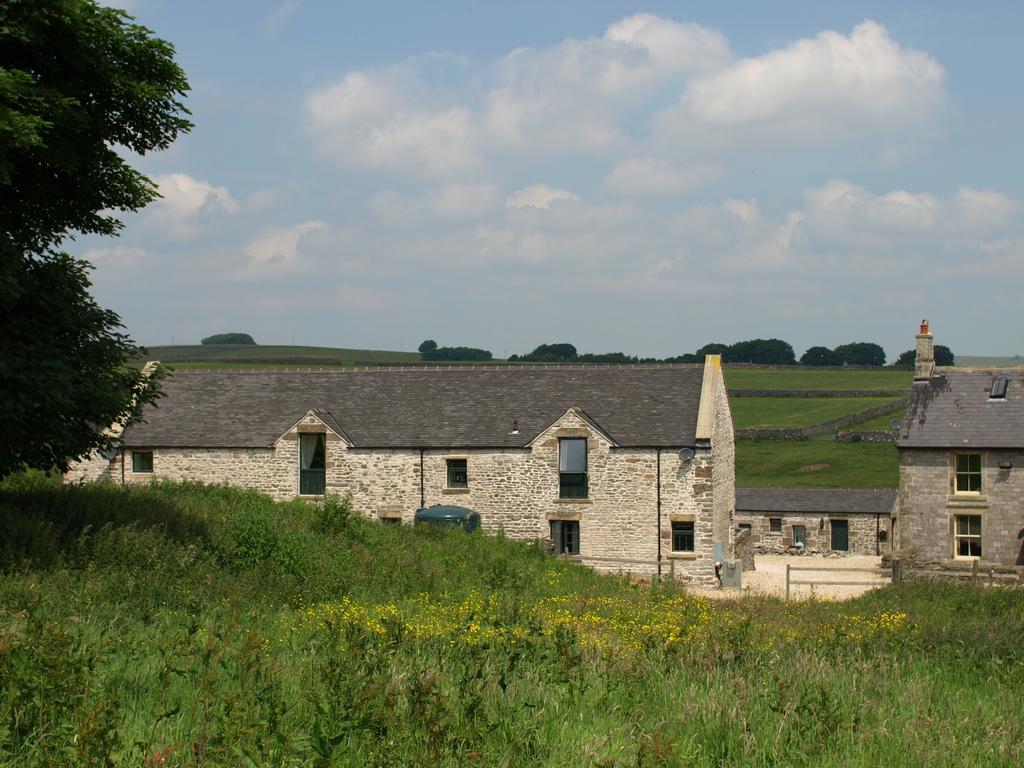In one or two sentences, can you explain what this image depicts? In this image, we can see grass on the ground, we can see some trees, there are some buildings, we can see the windows on the buildings, at the top we can see the sky and some clouds. 